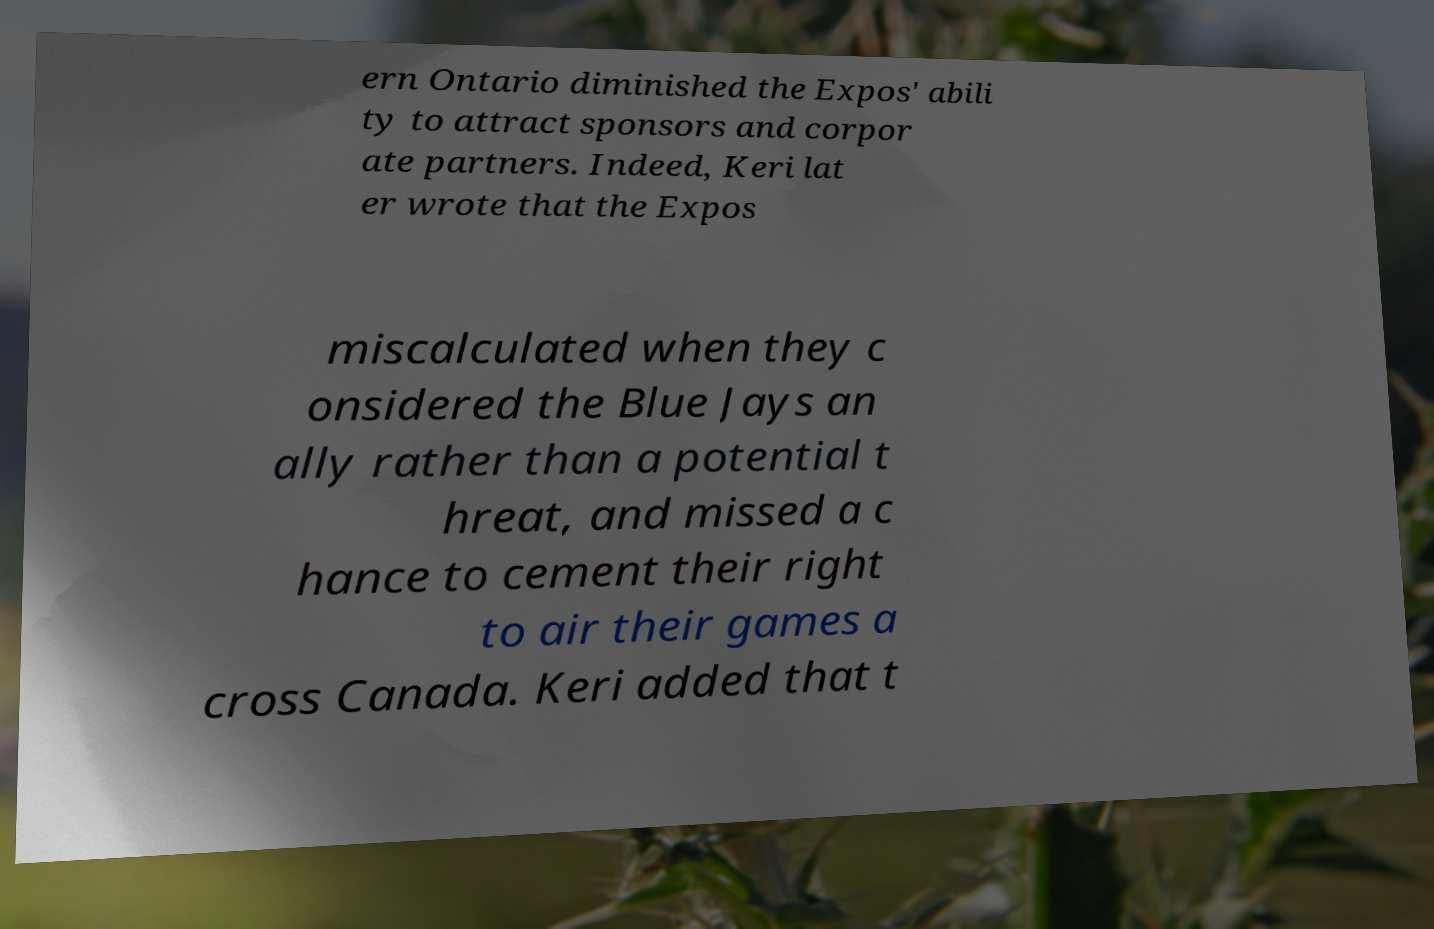For documentation purposes, I need the text within this image transcribed. Could you provide that? ern Ontario diminished the Expos' abili ty to attract sponsors and corpor ate partners. Indeed, Keri lat er wrote that the Expos miscalculated when they c onsidered the Blue Jays an ally rather than a potential t hreat, and missed a c hance to cement their right to air their games a cross Canada. Keri added that t 